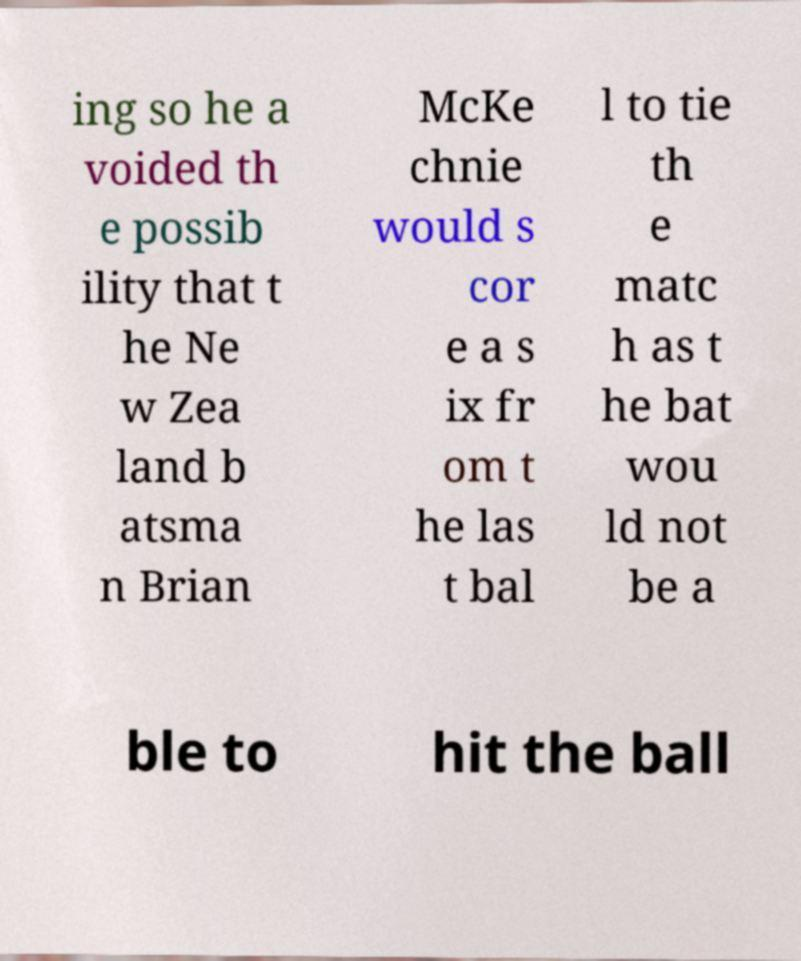Can you read and provide the text displayed in the image?This photo seems to have some interesting text. Can you extract and type it out for me? ing so he a voided th e possib ility that t he Ne w Zea land b atsma n Brian McKe chnie would s cor e a s ix fr om t he las t bal l to tie th e matc h as t he bat wou ld not be a ble to hit the ball 